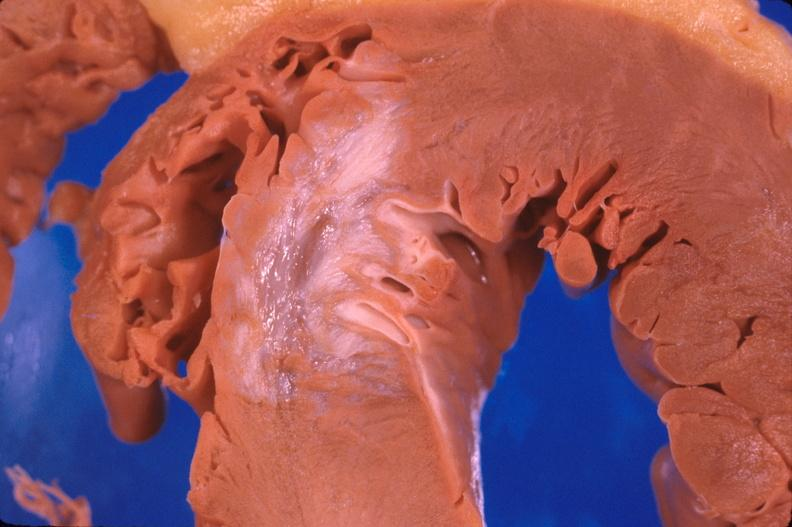how does this image show heart, old myocardial infarction?
Answer the question using a single word or phrase. With fibrosis 